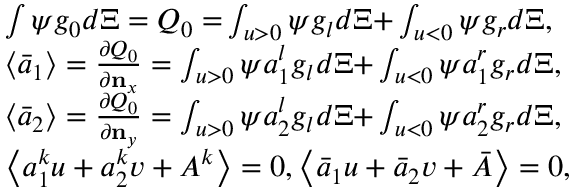<formula> <loc_0><loc_0><loc_500><loc_500>\begin{array} { r l } & { \int { \psi { { g } _ { 0 } } d \Xi = { { Q } _ { 0 } } = } \int _ { u > 0 } { \psi { { g } _ { l } } d \Xi + } \int _ { u < 0 } { \psi { { g } _ { r } } d \Xi } , } \\ & { \left \langle { { { \bar { a } } } _ { 1 } } \right \rangle = \frac { \partial { { Q } _ { 0 } } } { \partial { { n } _ { x } } } = \int _ { u > 0 } { \psi a _ { 1 } ^ { l } { { g } _ { l } } d \Xi + } \int _ { u < 0 } { \psi a _ { 1 } ^ { r } { { g } _ { r } } d \Xi } , } \\ & { \left \langle { { { \bar { a } } } _ { 2 } } \right \rangle = \frac { \partial { { Q } _ { 0 } } } { \partial { { n } _ { y } } } = \int _ { u > 0 } { \psi a _ { 2 } ^ { l } { { g } _ { l } } d \Xi + } \int _ { u < 0 } { \psi a _ { 2 } ^ { r } { { g } _ { r } } d \Xi } , } \\ & { \left \langle a _ { 1 } ^ { k } u + a _ { 2 } ^ { k } v + { { A } ^ { k } } \right \rangle = 0 , \left \langle { { { \bar { a } } } _ { 1 } } u + { { { \bar { a } } } _ { 2 } } v + \bar { A } \right \rangle = 0 , } \end{array}</formula> 